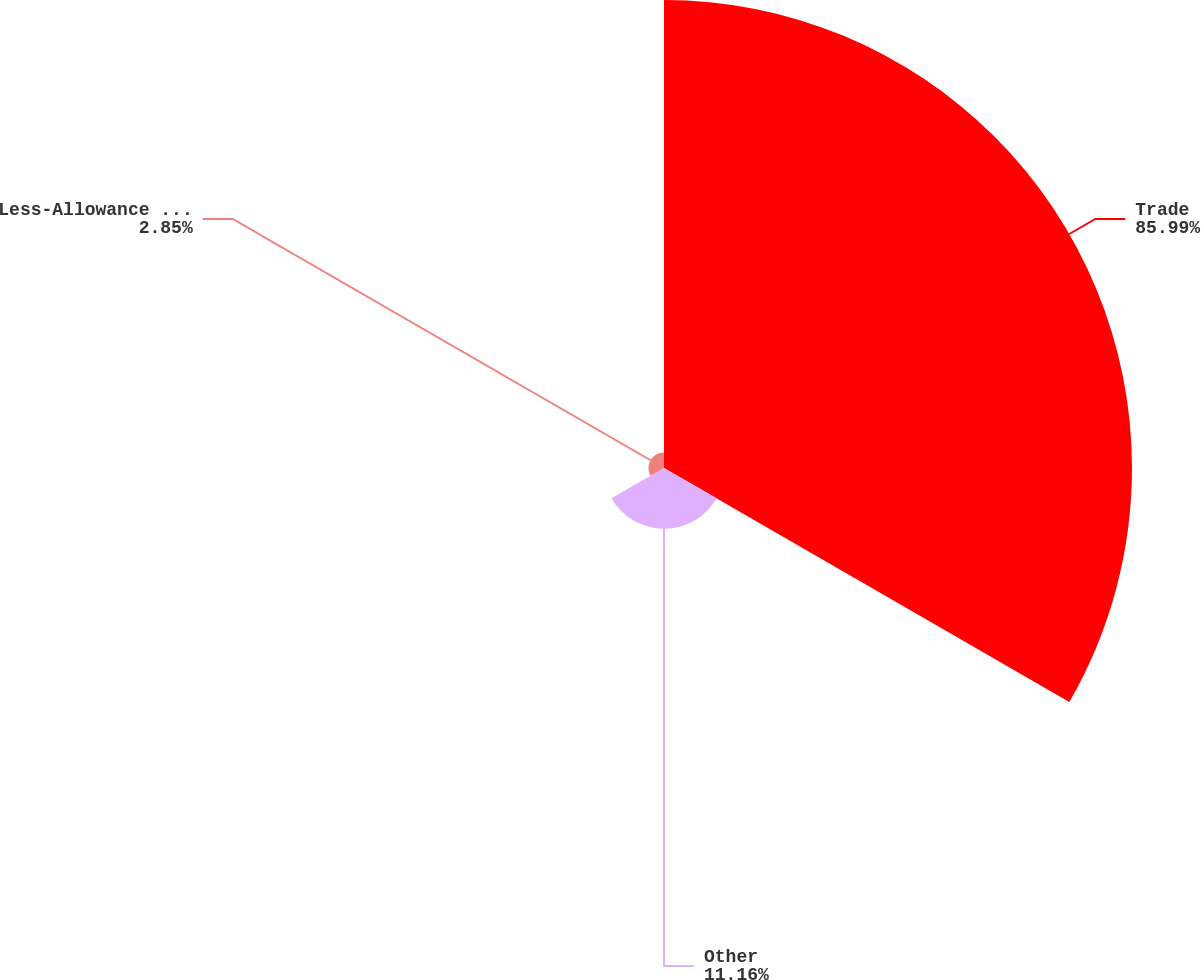Convert chart to OTSL. <chart><loc_0><loc_0><loc_500><loc_500><pie_chart><fcel>Trade<fcel>Other<fcel>Less-Allowance for doubtful<nl><fcel>85.98%<fcel>11.16%<fcel>2.85%<nl></chart> 